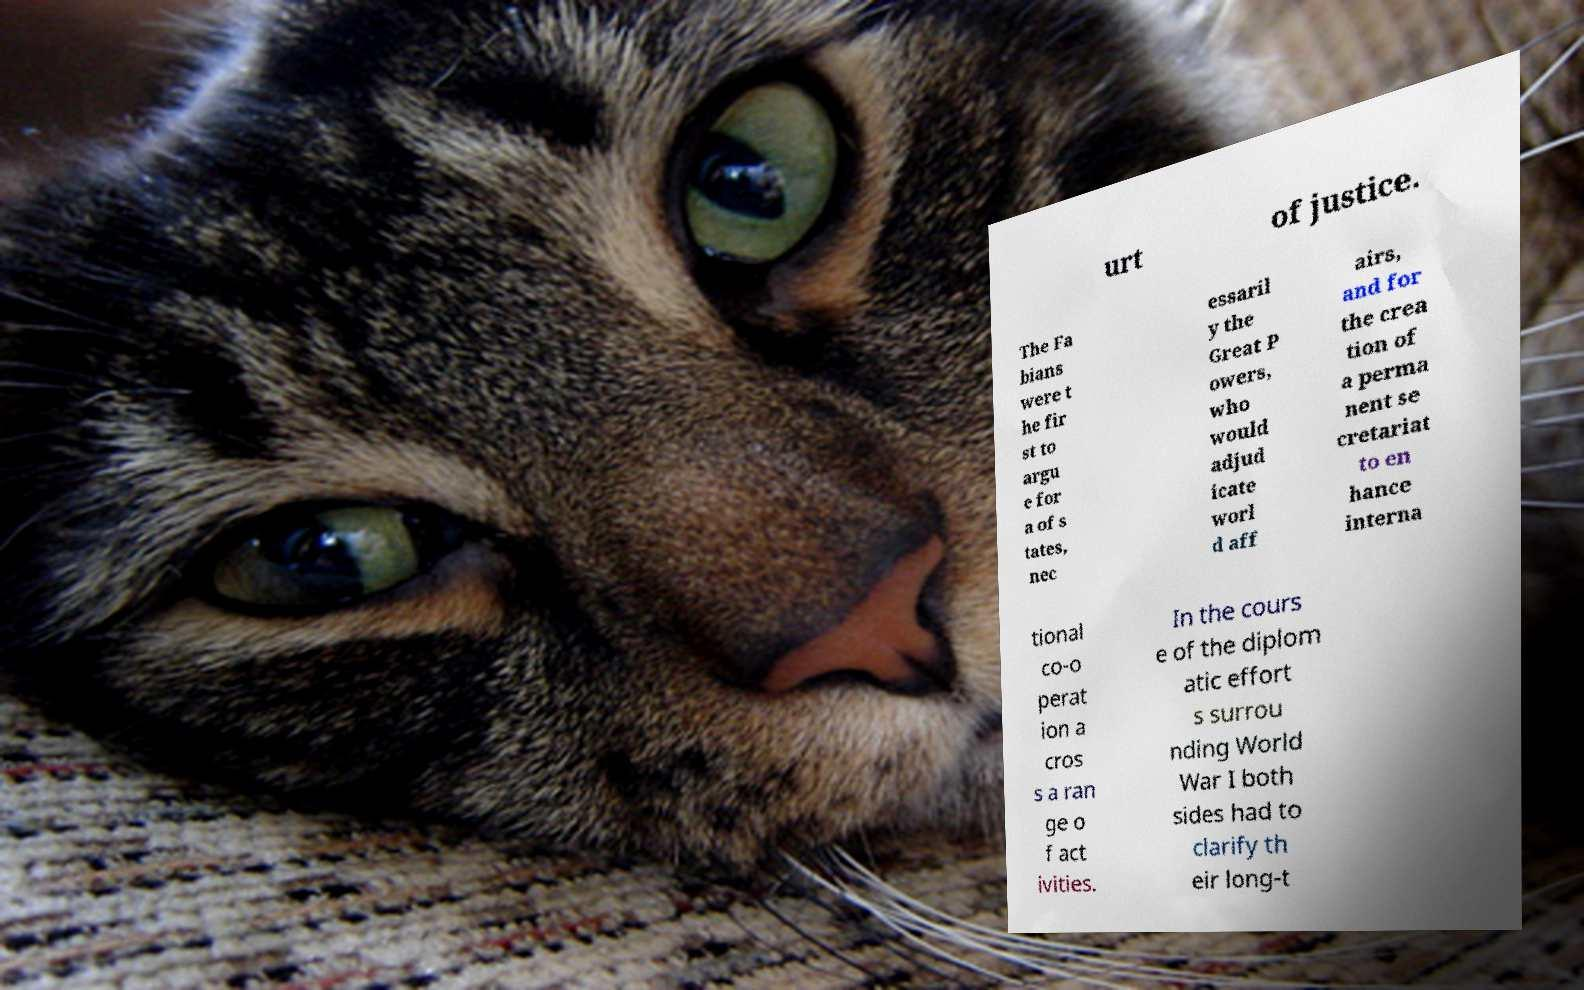Can you read and provide the text displayed in the image?This photo seems to have some interesting text. Can you extract and type it out for me? urt of justice. The Fa bians were t he fir st to argu e for a of s tates, nec essaril y the Great P owers, who would adjud icate worl d aff airs, and for the crea tion of a perma nent se cretariat to en hance interna tional co-o perat ion a cros s a ran ge o f act ivities. In the cours e of the diplom atic effort s surrou nding World War I both sides had to clarify th eir long-t 